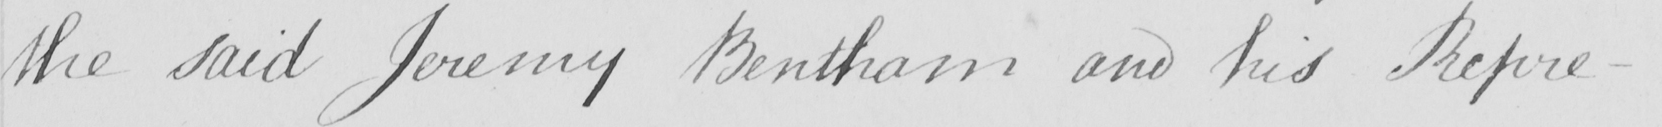Please transcribe the handwritten text in this image. the said Jeremy Bentham and his Repre- 